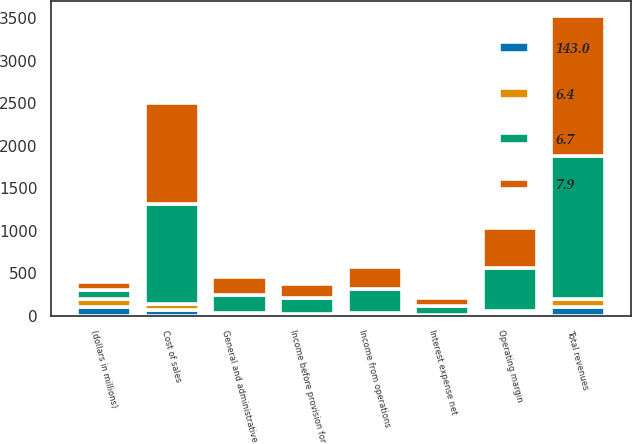Convert chart. <chart><loc_0><loc_0><loc_500><loc_500><stacked_bar_chart><ecel><fcel>(dollars in millions)<fcel>Total revenues<fcel>Cost of sales<fcel>Operating margin<fcel>General and administrative<fcel>Income from operations<fcel>Interest expense net<fcel>Income before provision for<nl><fcel>7.9<fcel>100<fcel>1652.2<fcel>1181.7<fcel>470.5<fcel>211.4<fcel>259.1<fcel>91.3<fcel>167.8<nl><fcel>6.4<fcel>100<fcel>100<fcel>71.5<fcel>28.5<fcel>12.8<fcel>15.7<fcel>5.5<fcel>10.2<nl><fcel>6.7<fcel>100<fcel>1678.4<fcel>1177.1<fcel>501.3<fcel>219<fcel>282.3<fcel>101.1<fcel>181.2<nl><fcel>143<fcel>100<fcel>100<fcel>70.1<fcel>29.9<fcel>13.1<fcel>16.8<fcel>6<fcel>10.8<nl></chart> 